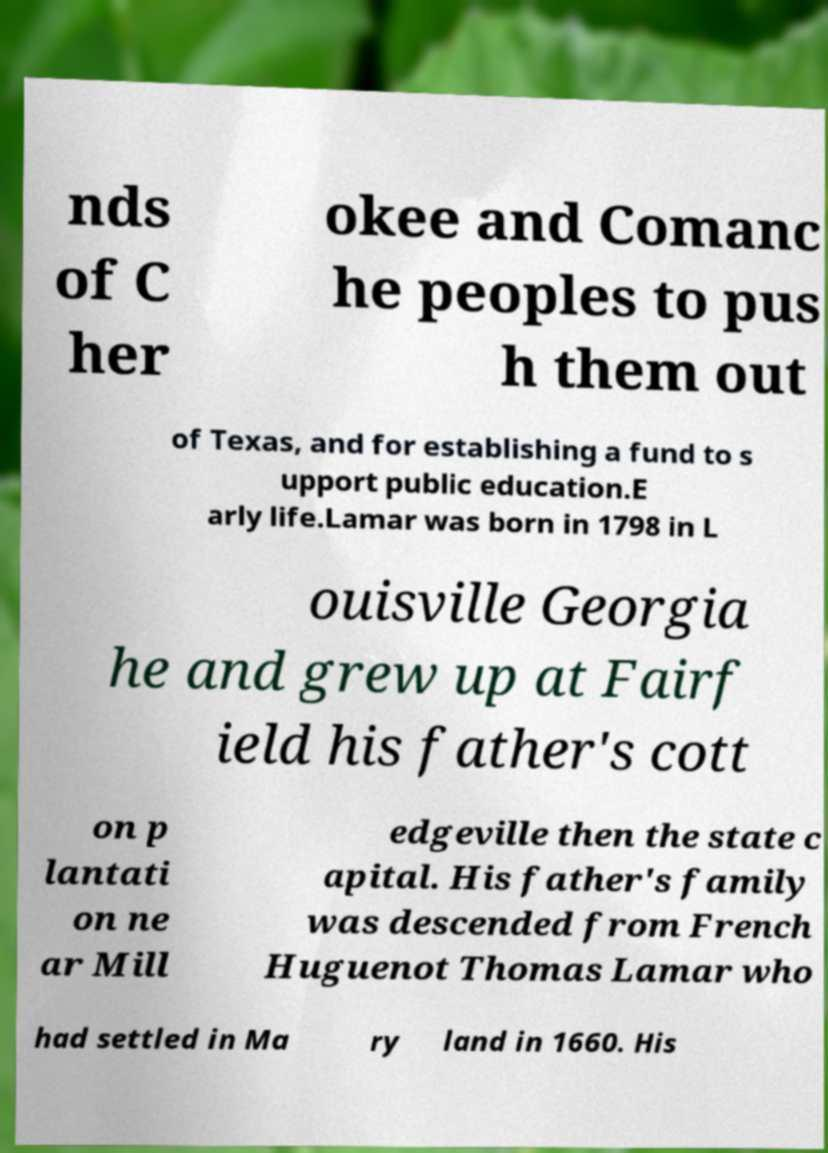Could you assist in decoding the text presented in this image and type it out clearly? nds of C her okee and Comanc he peoples to pus h them out of Texas, and for establishing a fund to s upport public education.E arly life.Lamar was born in 1798 in L ouisville Georgia he and grew up at Fairf ield his father's cott on p lantati on ne ar Mill edgeville then the state c apital. His father's family was descended from French Huguenot Thomas Lamar who had settled in Ma ry land in 1660. His 